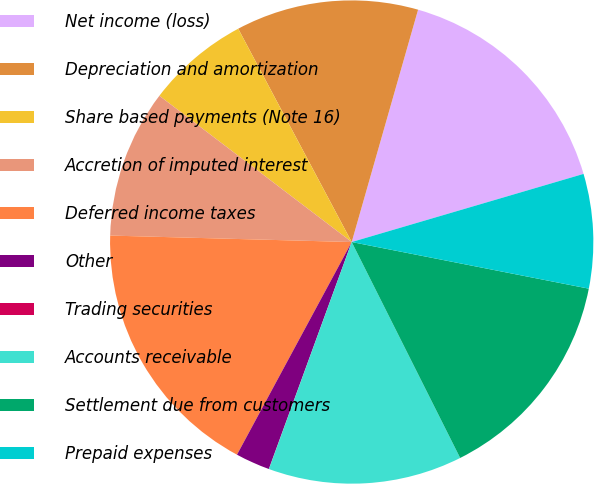<chart> <loc_0><loc_0><loc_500><loc_500><pie_chart><fcel>Net income (loss)<fcel>Depreciation and amortization<fcel>Share based payments (Note 16)<fcel>Accretion of imputed interest<fcel>Deferred income taxes<fcel>Other<fcel>Trading securities<fcel>Accounts receivable<fcel>Settlement due from customers<fcel>Prepaid expenses<nl><fcel>16.02%<fcel>12.21%<fcel>6.87%<fcel>9.92%<fcel>17.55%<fcel>2.3%<fcel>0.01%<fcel>12.97%<fcel>14.5%<fcel>7.64%<nl></chart> 